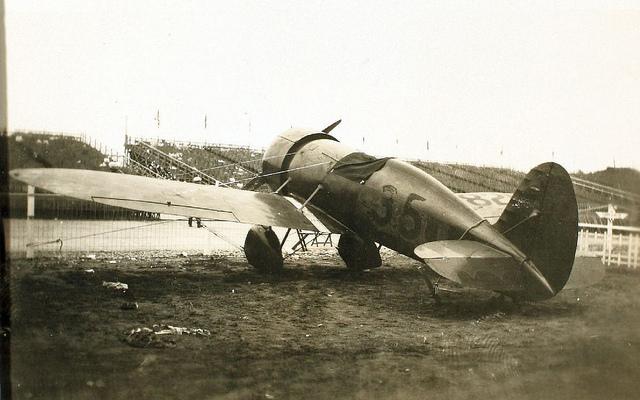What number is on the plane?
Keep it brief. 35. Is the engine on?
Concise answer only. No. Does this plane have a propeller?
Quick response, please. Yes. 